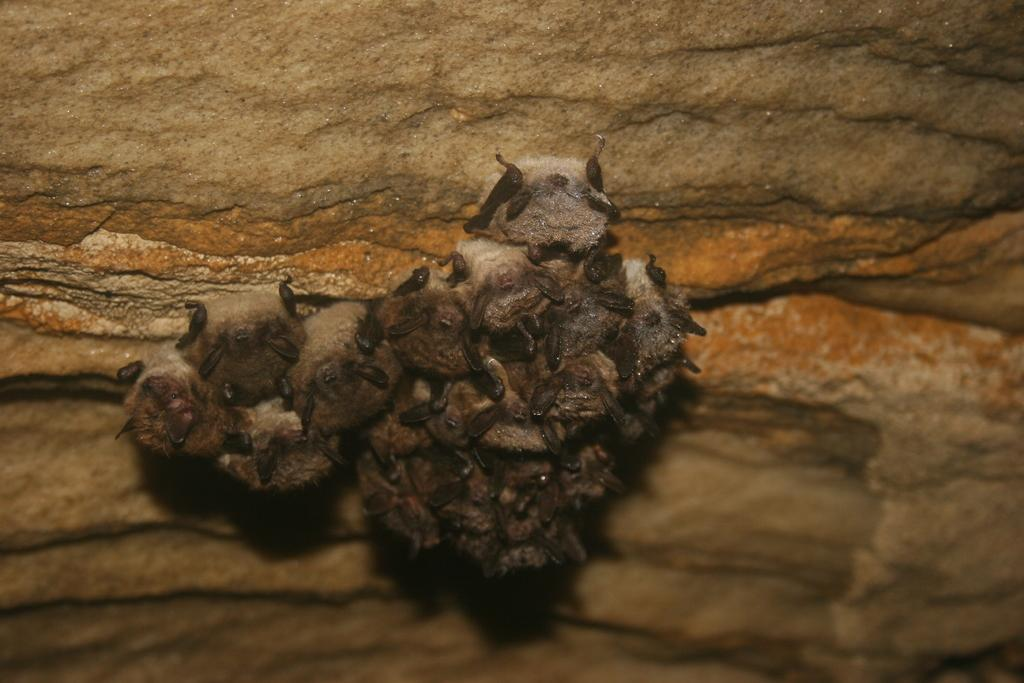What type of animal is in the image? There is a little brown bat in the image. What type of truck can be seen in the image? There is no truck present in the image; it features a little brown bat. 